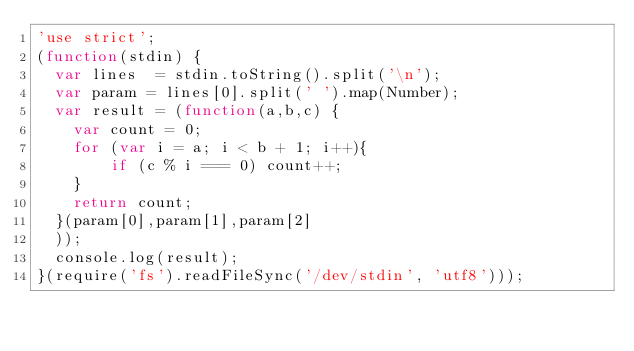<code> <loc_0><loc_0><loc_500><loc_500><_JavaScript_>'use strict';
(function(stdin) {
  var lines  = stdin.toString().split('\n');
  var param = lines[0].split(' ').map(Number);
  var result = (function(a,b,c) {
    var count = 0;
    for (var i = a; i < b + 1; i++){
        if (c % i === 0) count++;
    }
    return count;
  }(param[0],param[1],param[2]
  ));
  console.log(result);
}(require('fs').readFileSync('/dev/stdin', 'utf8')));</code> 